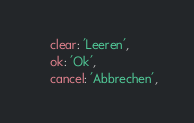<code> <loc_0><loc_0><loc_500><loc_500><_JavaScript_>    clear: 'Leeren',
    ok: 'Ok',
    cancel: 'Abbrechen',</code> 